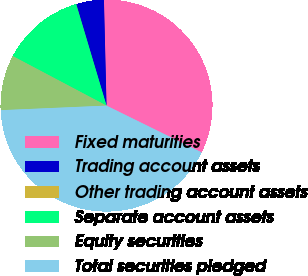Convert chart. <chart><loc_0><loc_0><loc_500><loc_500><pie_chart><fcel>Fixed maturities<fcel>Trading account assets<fcel>Other trading account assets<fcel>Separate account assets<fcel>Equity securities<fcel>Total securities pledged<nl><fcel>32.67%<fcel>4.22%<fcel>0.02%<fcel>12.63%<fcel>8.43%<fcel>42.04%<nl></chart> 